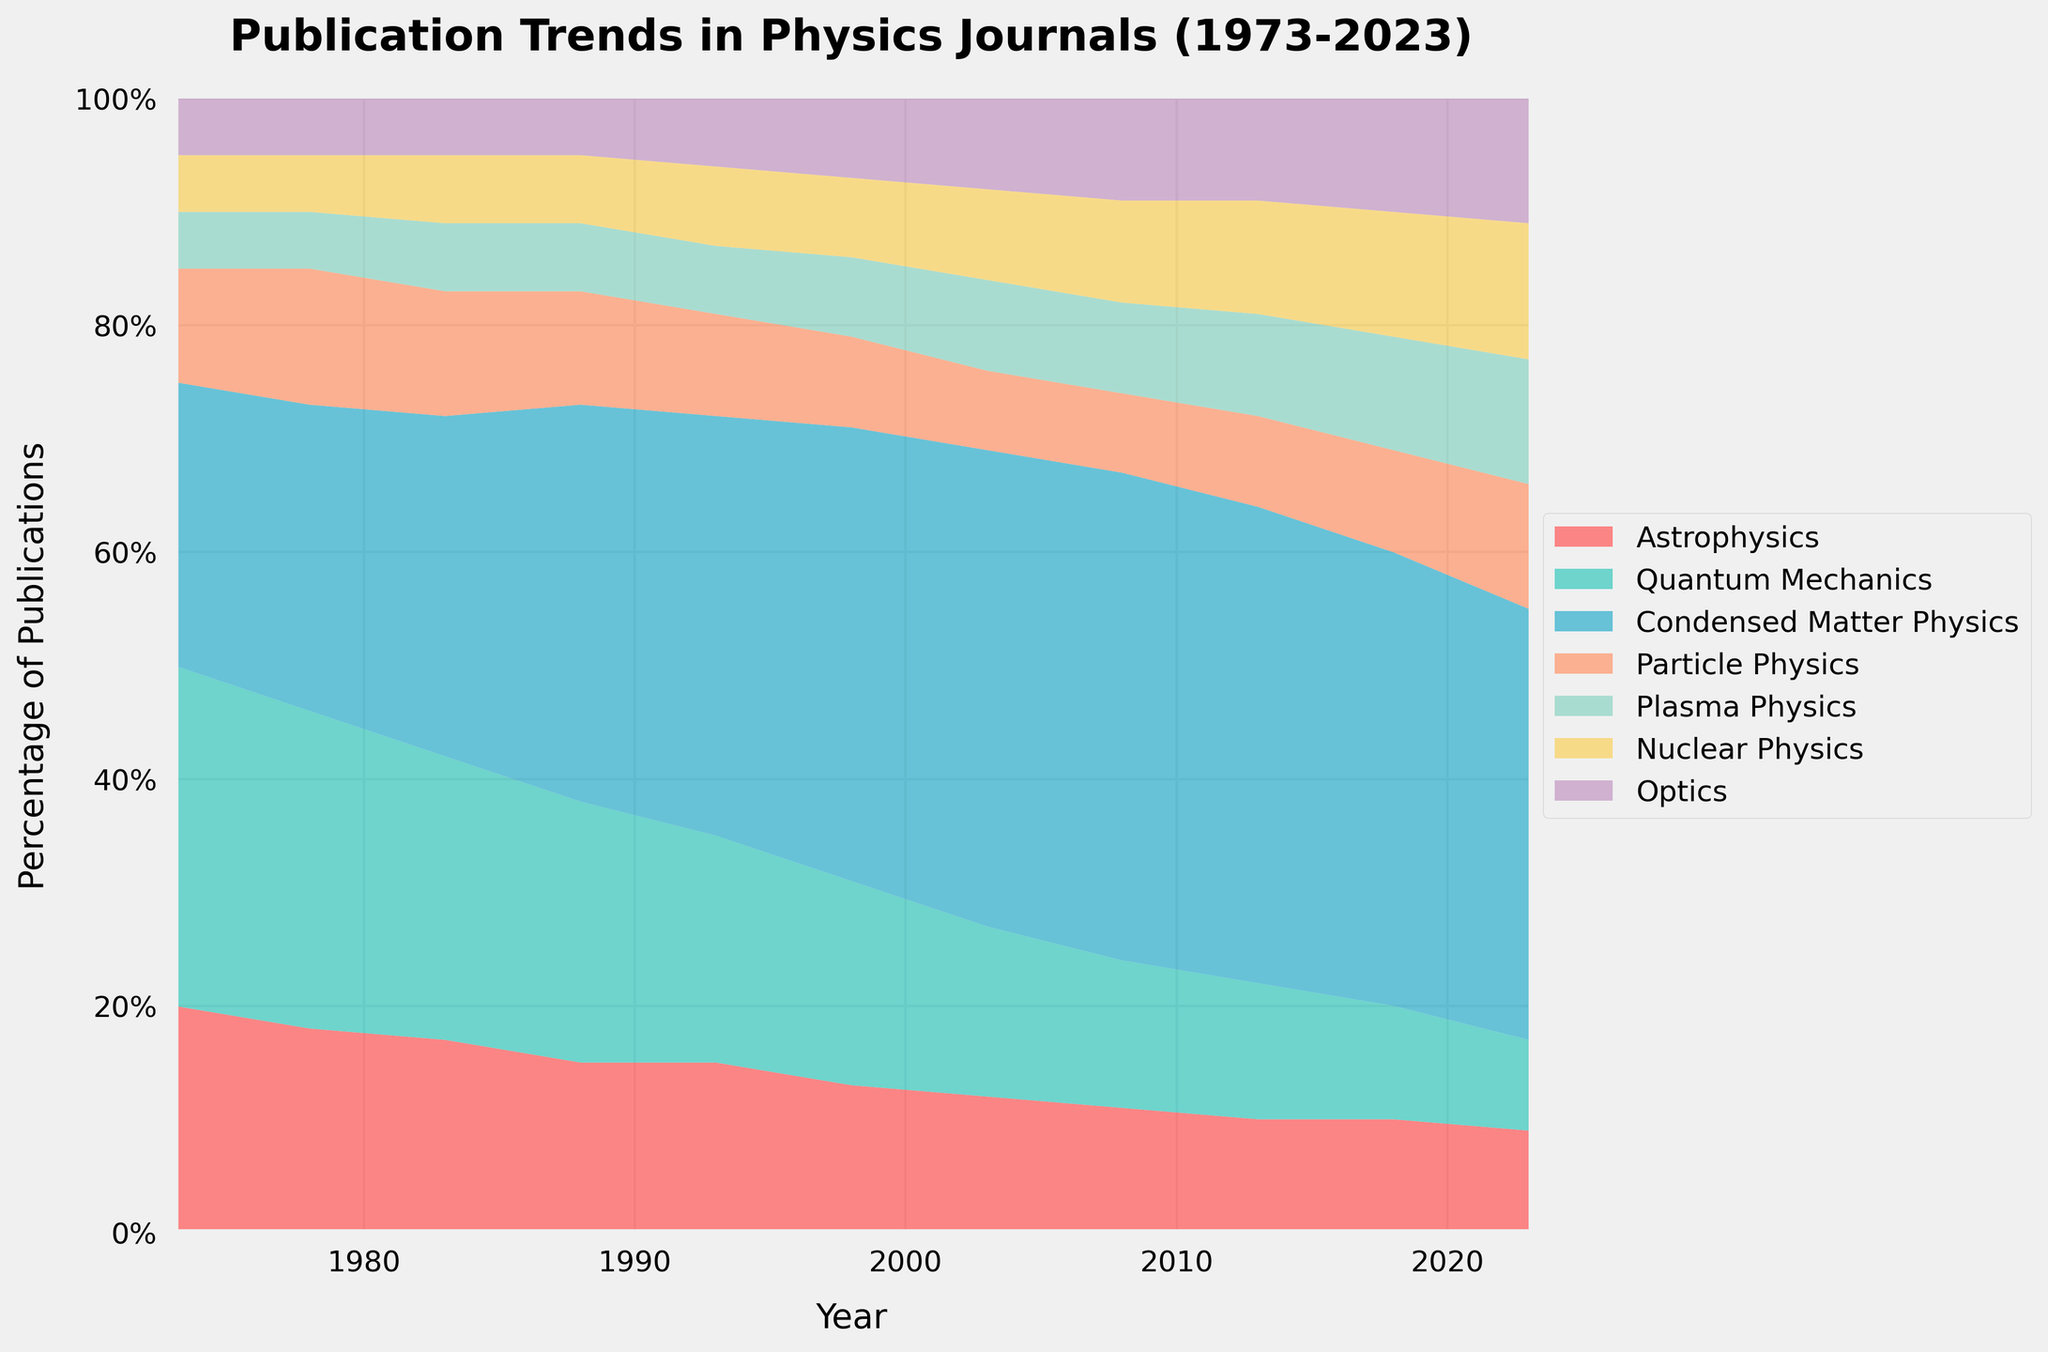What is the title of the figure? The title of a figure is usually written at the top and provides an overview of what the data is about. Here, the title is clear and states the subject of the figure.
Answer: "Publication Trends in Physics Journals (1973-2023)" What field had the highest percentage of publications in 1973? To determine this, look at the stacked area sections for the year 1973. The field with the widest section at this year is Quantum Mechanics.
Answer: Quantum Mechanics Which subfield shows a consistent increase in its share of publications over the 50 years? Analyzing each subfield's trend line, we see that Nuclear Physics shows a consistent increase from 5% in 1973 to 12% in 2023.
Answer: Nuclear Physics By how much did the percentage of Condensed Matter Physics publications change from 1973 to 2023? The percentage of Condensed Matter Physics starts at 25% in 1973 and increases to 38% in 2023. Subtract the initial value from the final value: 38% - 25% = 13%.
Answer: 13% In which year did Optics publications reach 10% for the first time? By observing the Optics area in the chart, it reaches 10% for the first time in the year 2018.
Answer: 2018 How does the trend for Particle Physics publications change over the span of 50 years? For trend analysis, look at the Particle Physics area from 1973 to 2023. It starts at 10% in 1973, dips slightly, remains relatively stable, and then increases to 11% by 2023.
Answer: Relatively stable with a slight increase toward the end Which two subfields had nearly equal publication percentages in 2018? In 2018, observe the segments' sizes. Optics and Plasma Physics both have publication percentages around 10%.
Answer: Optics and Plasma Physics Compare the trends of Astrophysics and Quantum Mechanics over the years. Astrophysics starts at 20% in 1973 and declines to 9% in 2023, whereas Quantum Mechanics starts at 30% in 1973 and declines to 8% in 2023. Both show a decreasing trend.
Answer: Both show a decreasing trend What is the overall trend for the percentage of publications in Astrophysics? Observe the Astrophysics segment from 1973 to 2023. The percentage starts at 20% and steadily declines to 9%.
Answer: Steady decline 